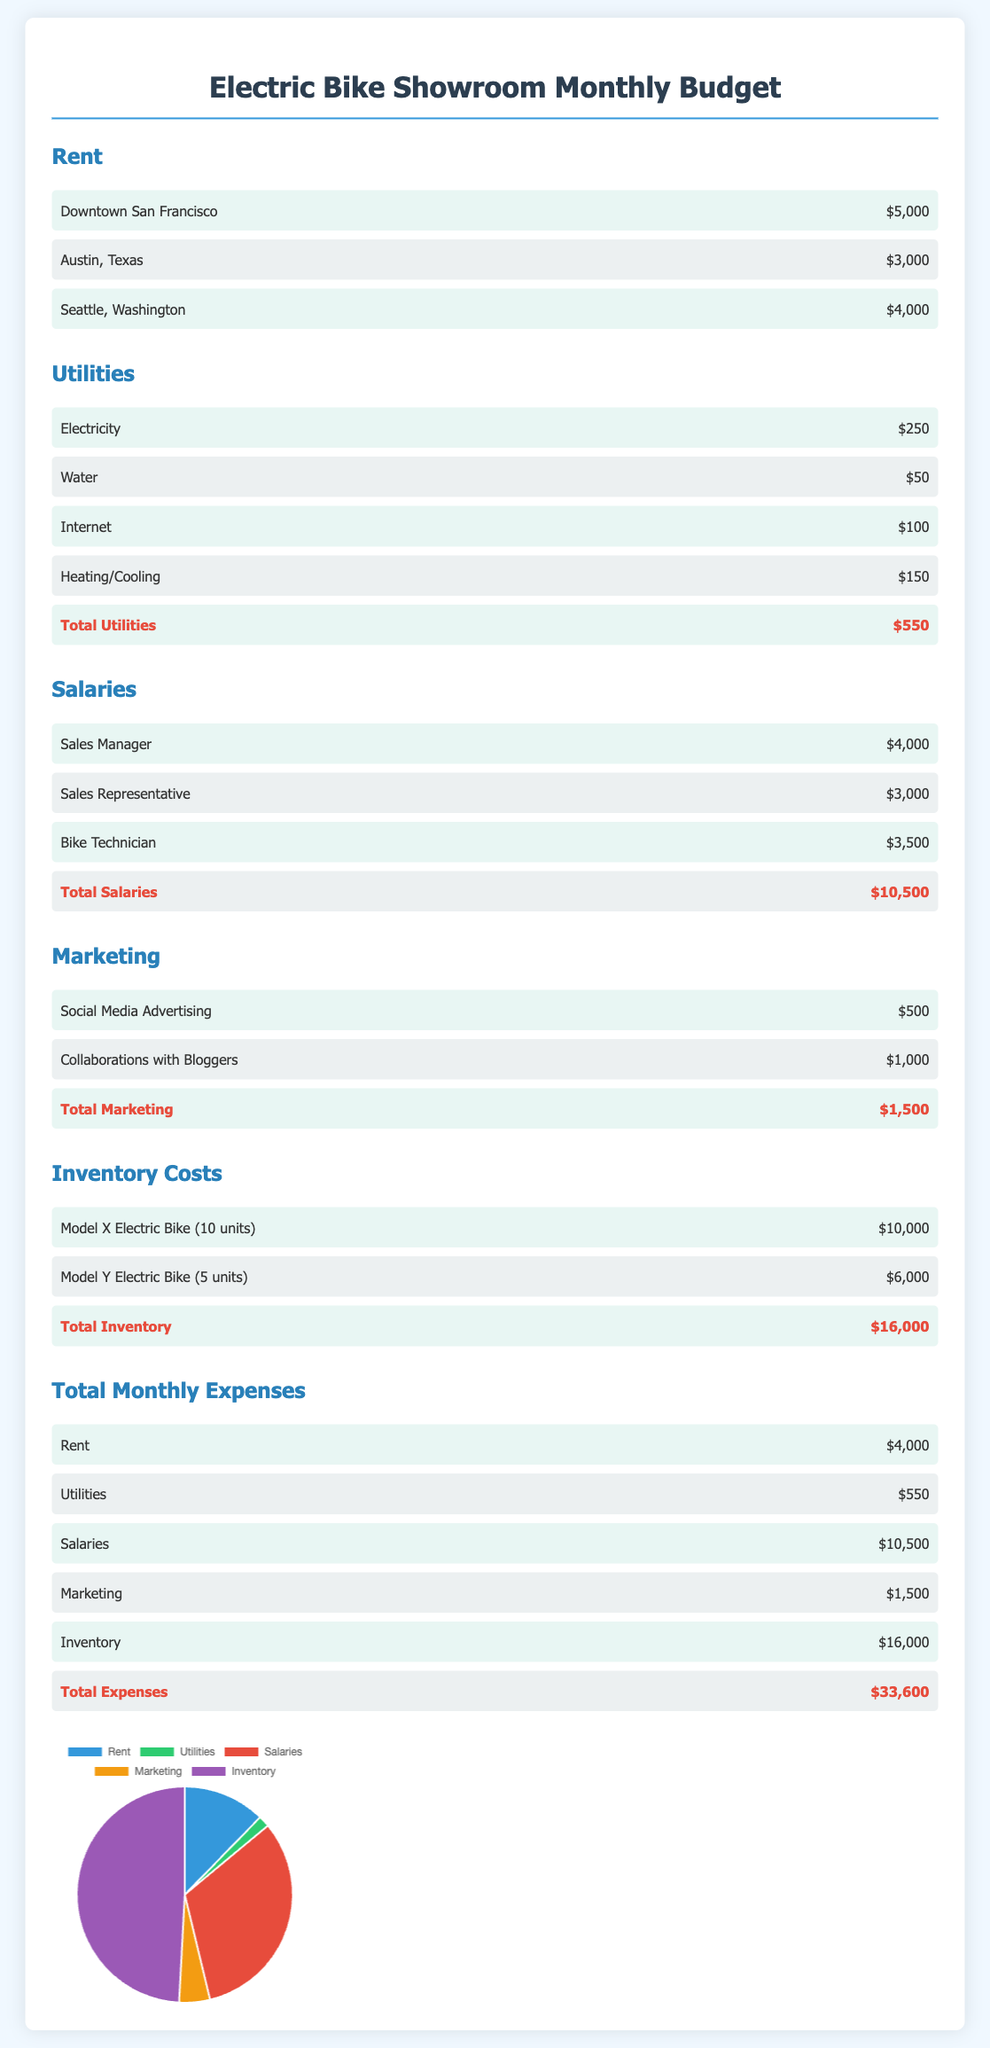What is the total rent for the showroom? The total rent for the showroom is derived from the location-specific rents listed, and in this case, it's taken as $4,000.
Answer: $4,000 What is the monthly expense for electricity? The monthly expense for electricity is specifically stated in the utilities section of the document.
Answer: $250 How much are salaries for the Sales Representative? The salary for the Sales Representative is detailed in the salaries section.
Answer: $3,000 What is the total cost for inventory? The total inventory cost is the sum of the costs for the electric bike models mentioned in the document.
Answer: $16,000 Which city has the highest rent listed? The rent amounts for different cities show that Downtown San Francisco has the highest figure.
Answer: Downtown San Francisco What percentage of total expenses is spent on salaries? Salaries account for $10,500 out of the total expenses of $33,600, which is calculated for the percentage.
Answer: 31.25% What are the total utilities costs? The total utilities costs are listed at the bottom of the utilities section, which is the sum of all utilities expenses.
Answer: $550 What marketing expense is associated with collaborations? The specific expense for collaborations with bloggers is detailed in the marketing section of the document.
Answer: $1,000 How much is the total for marketing expenses? The total marketing expenses are outlined at the end of the marketing section, summarizing the monthly costs.
Answer: $1,500 